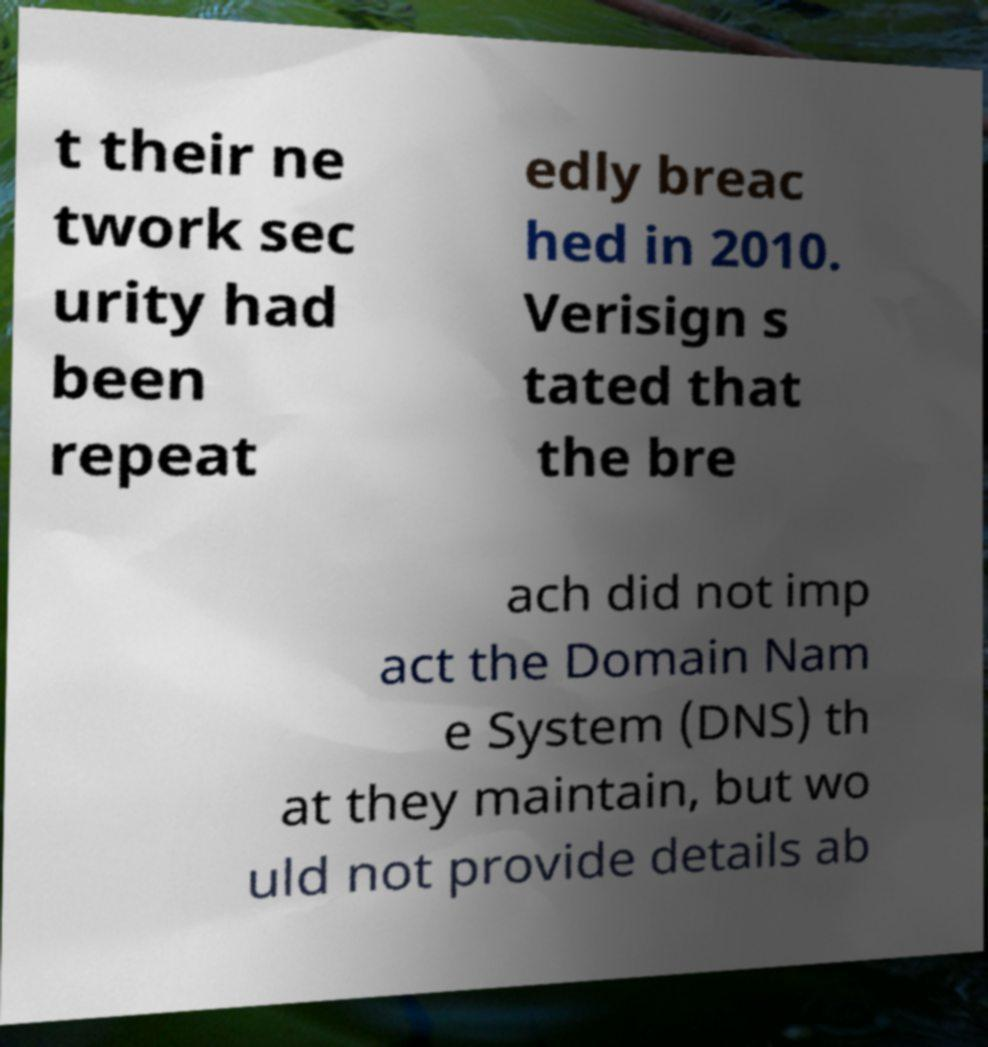I need the written content from this picture converted into text. Can you do that? t their ne twork sec urity had been repeat edly breac hed in 2010. Verisign s tated that the bre ach did not imp act the Domain Nam e System (DNS) th at they maintain, but wo uld not provide details ab 